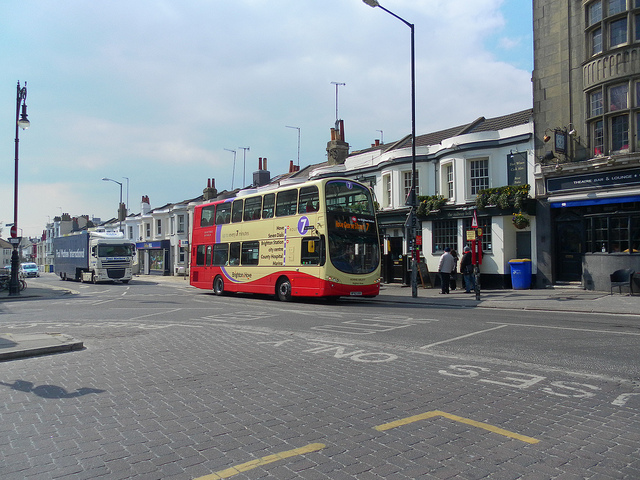Please transcribe the text in this image. SES 